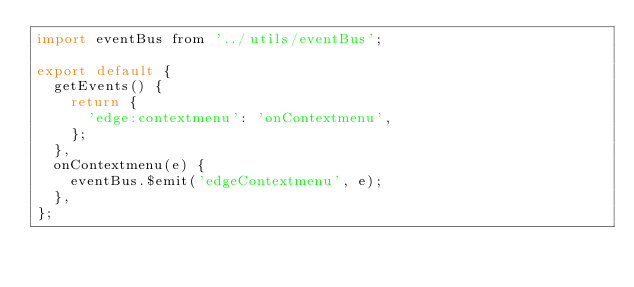<code> <loc_0><loc_0><loc_500><loc_500><_JavaScript_>import eventBus from '../utils/eventBus';

export default {
  getEvents() {
    return {
      'edge:contextmenu': 'onContextmenu',
    };
  },
  onContextmenu(e) {
    eventBus.$emit('edgeContextmenu', e);
  },
};
</code> 